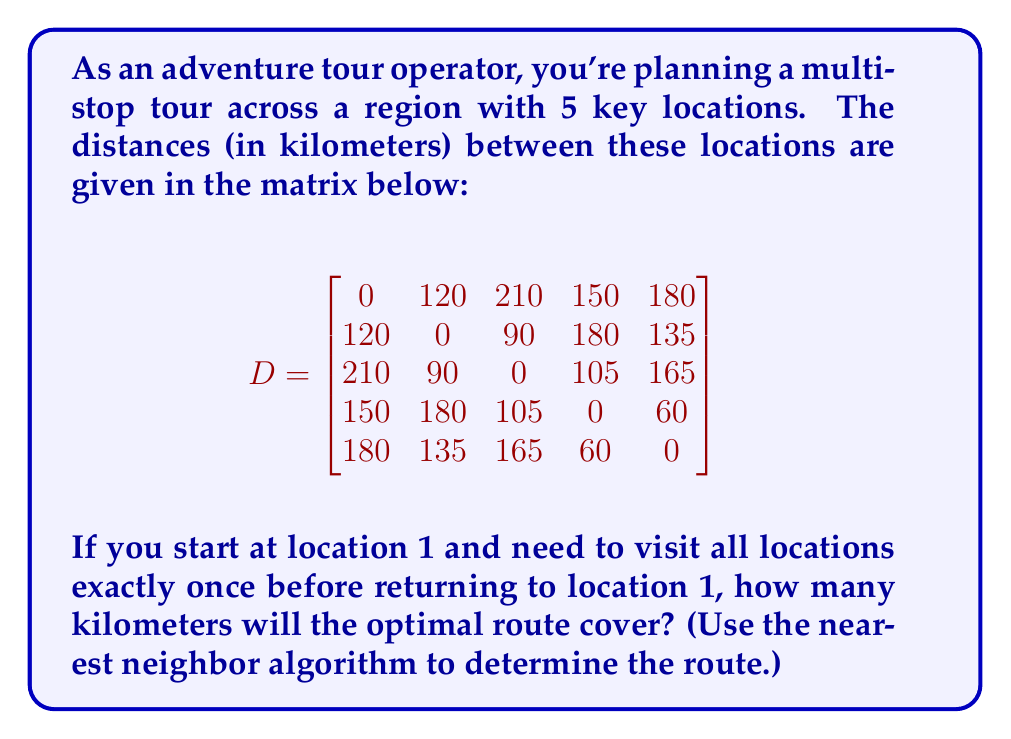Can you solve this math problem? To solve this problem, we'll use the nearest neighbor algorithm, which is a heuristic method for solving the Traveling Salesman Problem. Here's how it works:

1. Start at location 1.
2. Find the nearest unvisited location and move there.
3. Repeat step 2 until all locations have been visited.
4. Return to location 1.

Let's apply this algorithm:

1. Start at location 1.

2. From location 1, the nearest location is 2 (120 km).
   Route so far: 1 → 2
   Distance: 120 km

3. From location 2, the nearest unvisited location is 3 (90 km).
   Route so far: 1 → 2 → 3
   Distance: 120 + 90 = 210 km

4. From location 3, the nearest unvisited location is 4 (105 km).
   Route so far: 1 → 2 → 3 → 4
   Distance: 210 + 105 = 315 km

5. From location 4, the only unvisited location is 5 (60 km).
   Route so far: 1 → 2 → 3 → 4 → 5
   Distance: 315 + 60 = 375 km

6. Finally, return to location 1 from location 5 (180 km).
   Complete route: 1 → 2 → 3 → 4 → 5 → 1
   Total distance: 375 + 180 = 555 km

Therefore, the optimal route according to the nearest neighbor algorithm covers 555 kilometers.
Answer: 555 kilometers 